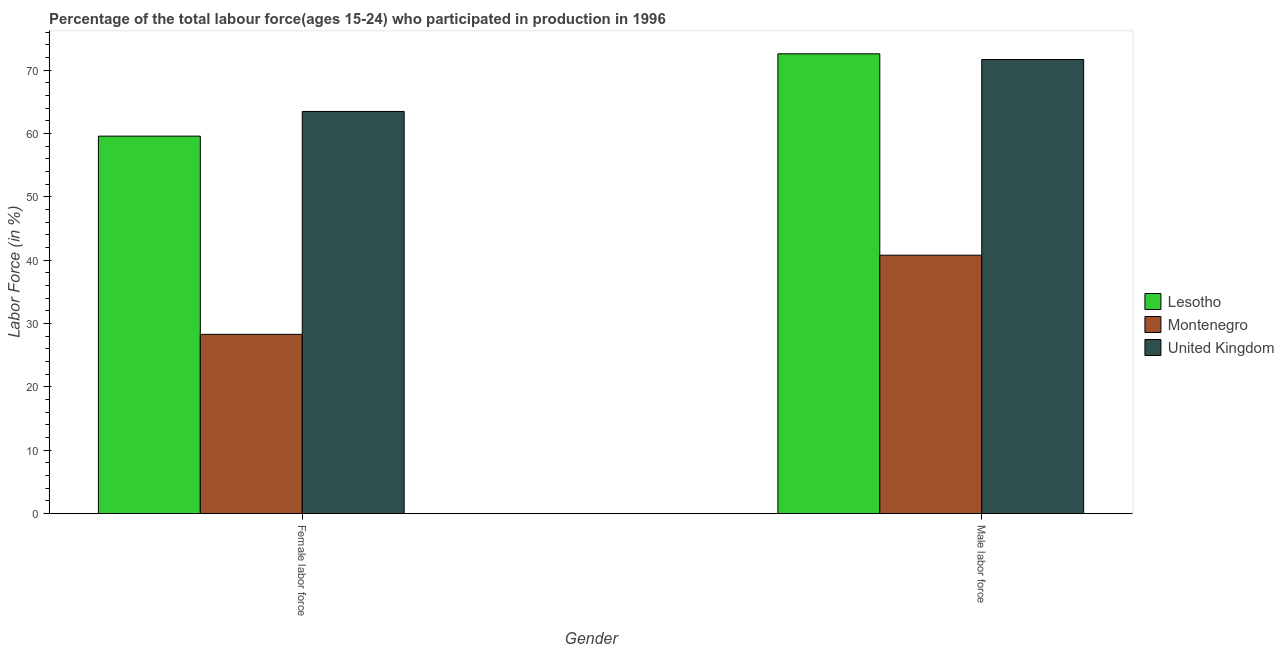How many groups of bars are there?
Make the answer very short. 2. Are the number of bars per tick equal to the number of legend labels?
Keep it short and to the point. Yes. Are the number of bars on each tick of the X-axis equal?
Offer a very short reply. Yes. How many bars are there on the 2nd tick from the right?
Give a very brief answer. 3. What is the label of the 1st group of bars from the left?
Ensure brevity in your answer.  Female labor force. What is the percentage of male labour force in Montenegro?
Your answer should be very brief. 40.8. Across all countries, what is the maximum percentage of male labour force?
Your answer should be very brief. 72.6. Across all countries, what is the minimum percentage of male labour force?
Your answer should be compact. 40.8. In which country was the percentage of male labour force maximum?
Keep it short and to the point. Lesotho. In which country was the percentage of male labour force minimum?
Keep it short and to the point. Montenegro. What is the total percentage of female labor force in the graph?
Keep it short and to the point. 151.4. What is the difference between the percentage of female labor force in Lesotho and that in Montenegro?
Your response must be concise. 31.3. What is the difference between the percentage of male labour force in Montenegro and the percentage of female labor force in United Kingdom?
Keep it short and to the point. -22.7. What is the average percentage of male labour force per country?
Your response must be concise. 61.7. What is the difference between the percentage of male labour force and percentage of female labor force in Montenegro?
Give a very brief answer. 12.5. In how many countries, is the percentage of male labour force greater than 52 %?
Offer a terse response. 2. What is the ratio of the percentage of female labor force in Lesotho to that in United Kingdom?
Offer a terse response. 0.94. Is the percentage of male labour force in Montenegro less than that in United Kingdom?
Make the answer very short. Yes. In how many countries, is the percentage of female labor force greater than the average percentage of female labor force taken over all countries?
Your answer should be very brief. 2. What does the 2nd bar from the left in Male labor force represents?
Keep it short and to the point. Montenegro. What does the 3rd bar from the right in Female labor force represents?
Keep it short and to the point. Lesotho. Are all the bars in the graph horizontal?
Ensure brevity in your answer.  No. What is the difference between two consecutive major ticks on the Y-axis?
Your answer should be very brief. 10. Are the values on the major ticks of Y-axis written in scientific E-notation?
Your response must be concise. No. Does the graph contain any zero values?
Your answer should be compact. No. Where does the legend appear in the graph?
Provide a short and direct response. Center right. How many legend labels are there?
Keep it short and to the point. 3. How are the legend labels stacked?
Make the answer very short. Vertical. What is the title of the graph?
Keep it short and to the point. Percentage of the total labour force(ages 15-24) who participated in production in 1996. What is the label or title of the X-axis?
Your response must be concise. Gender. What is the label or title of the Y-axis?
Provide a short and direct response. Labor Force (in %). What is the Labor Force (in %) of Lesotho in Female labor force?
Give a very brief answer. 59.6. What is the Labor Force (in %) in Montenegro in Female labor force?
Your answer should be compact. 28.3. What is the Labor Force (in %) of United Kingdom in Female labor force?
Give a very brief answer. 63.5. What is the Labor Force (in %) in Lesotho in Male labor force?
Your answer should be compact. 72.6. What is the Labor Force (in %) in Montenegro in Male labor force?
Your response must be concise. 40.8. What is the Labor Force (in %) in United Kingdom in Male labor force?
Provide a succinct answer. 71.7. Across all Gender, what is the maximum Labor Force (in %) of Lesotho?
Make the answer very short. 72.6. Across all Gender, what is the maximum Labor Force (in %) in Montenegro?
Your response must be concise. 40.8. Across all Gender, what is the maximum Labor Force (in %) in United Kingdom?
Give a very brief answer. 71.7. Across all Gender, what is the minimum Labor Force (in %) of Lesotho?
Offer a terse response. 59.6. Across all Gender, what is the minimum Labor Force (in %) in Montenegro?
Offer a very short reply. 28.3. Across all Gender, what is the minimum Labor Force (in %) of United Kingdom?
Offer a very short reply. 63.5. What is the total Labor Force (in %) in Lesotho in the graph?
Keep it short and to the point. 132.2. What is the total Labor Force (in %) in Montenegro in the graph?
Offer a terse response. 69.1. What is the total Labor Force (in %) of United Kingdom in the graph?
Your answer should be very brief. 135.2. What is the difference between the Labor Force (in %) of Montenegro in Female labor force and that in Male labor force?
Your answer should be very brief. -12.5. What is the difference between the Labor Force (in %) of Montenegro in Female labor force and the Labor Force (in %) of United Kingdom in Male labor force?
Provide a short and direct response. -43.4. What is the average Labor Force (in %) of Lesotho per Gender?
Offer a terse response. 66.1. What is the average Labor Force (in %) in Montenegro per Gender?
Keep it short and to the point. 34.55. What is the average Labor Force (in %) of United Kingdom per Gender?
Offer a very short reply. 67.6. What is the difference between the Labor Force (in %) of Lesotho and Labor Force (in %) of Montenegro in Female labor force?
Your answer should be very brief. 31.3. What is the difference between the Labor Force (in %) in Lesotho and Labor Force (in %) in United Kingdom in Female labor force?
Give a very brief answer. -3.9. What is the difference between the Labor Force (in %) in Montenegro and Labor Force (in %) in United Kingdom in Female labor force?
Provide a short and direct response. -35.2. What is the difference between the Labor Force (in %) in Lesotho and Labor Force (in %) in Montenegro in Male labor force?
Provide a succinct answer. 31.8. What is the difference between the Labor Force (in %) in Montenegro and Labor Force (in %) in United Kingdom in Male labor force?
Ensure brevity in your answer.  -30.9. What is the ratio of the Labor Force (in %) of Lesotho in Female labor force to that in Male labor force?
Make the answer very short. 0.82. What is the ratio of the Labor Force (in %) of Montenegro in Female labor force to that in Male labor force?
Provide a short and direct response. 0.69. What is the ratio of the Labor Force (in %) of United Kingdom in Female labor force to that in Male labor force?
Your answer should be very brief. 0.89. What is the difference between the highest and the second highest Labor Force (in %) in Lesotho?
Provide a short and direct response. 13. What is the difference between the highest and the second highest Labor Force (in %) of Montenegro?
Make the answer very short. 12.5. What is the difference between the highest and the second highest Labor Force (in %) of United Kingdom?
Make the answer very short. 8.2. What is the difference between the highest and the lowest Labor Force (in %) of Lesotho?
Offer a terse response. 13. What is the difference between the highest and the lowest Labor Force (in %) in Montenegro?
Ensure brevity in your answer.  12.5. 